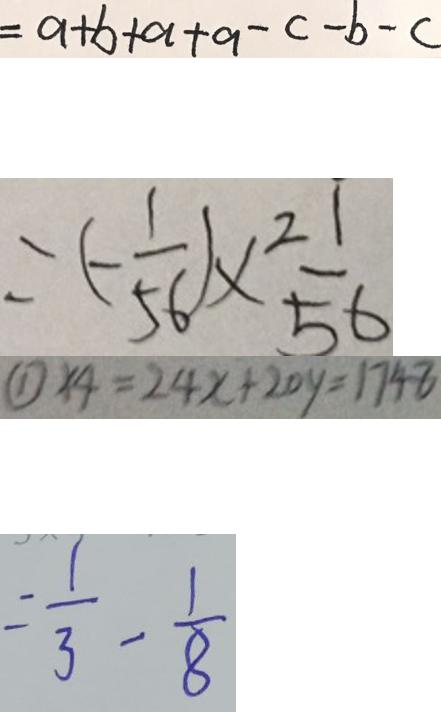Convert formula to latex. <formula><loc_0><loc_0><loc_500><loc_500>= a + b + a + a - c - b - c 
 = ( - \frac { 1 } { 5 6 } ) \times \frac { 2 1 } { 5 6 } 
 \textcircled { 1 } \times 4 = 2 4 x + 2 0 y = 1 7 4 8 
 = \frac { 1 } { 3 } - \frac { 1 } { 8 }</formula> 